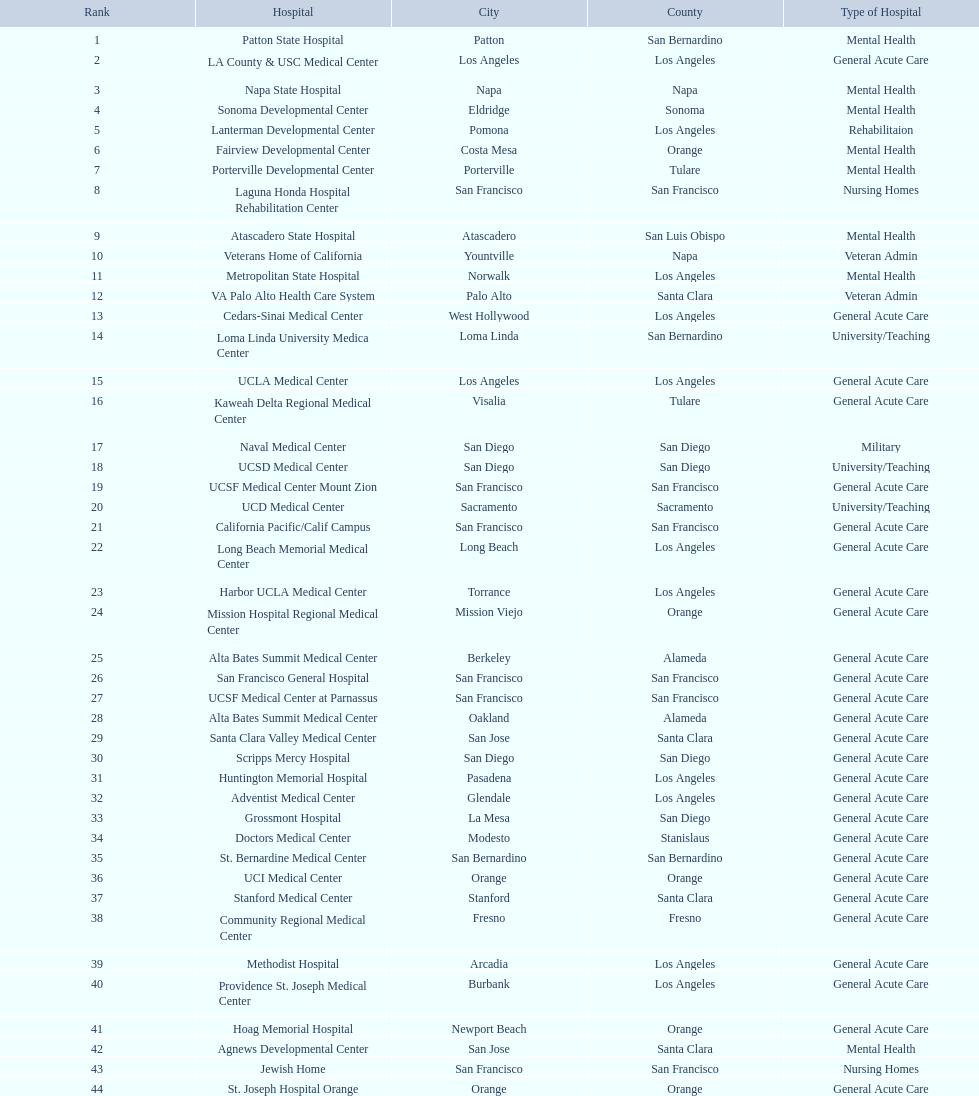Which type of hospitals are the same as grossmont hospital? General Acute Care. 